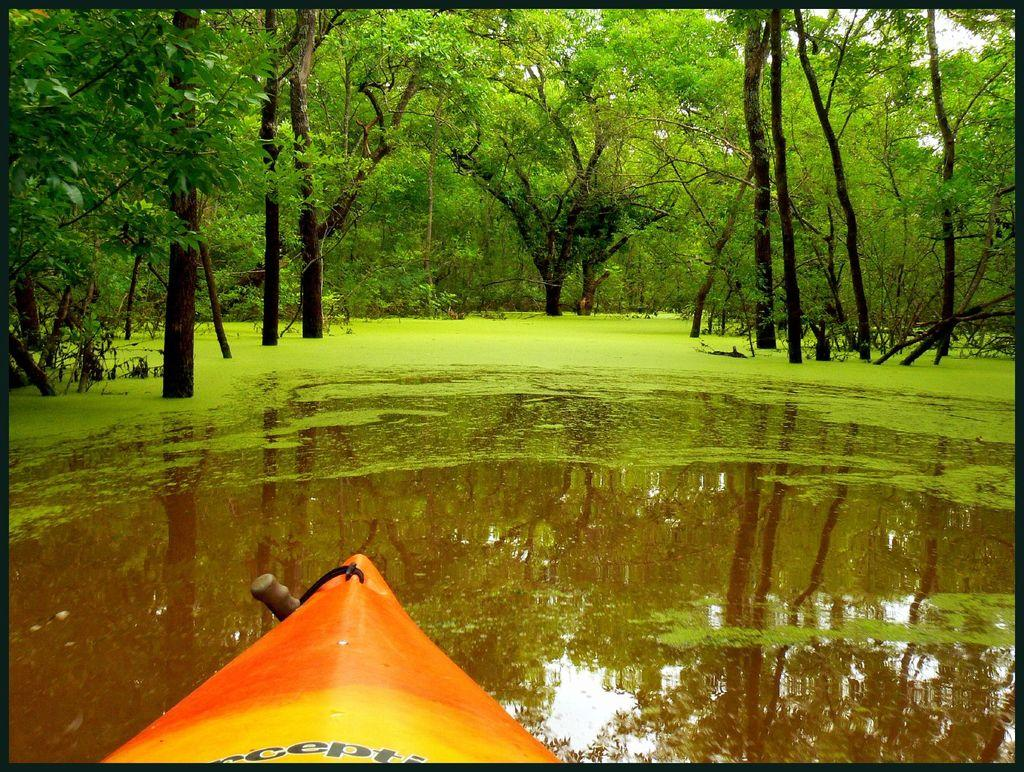What is at the bottom of the image? There is water at the bottom of the image. What is located above the water in the image? There is a boat above the water. What type of vegetation can be seen at the top of the image? There are trees at the top of the image. What color is the quince hanging from the roof in the image? There is no quince or roof present in the image. What is the sun's position in the image? The provided facts do not mention the sun, so its position cannot be determined from the image. 